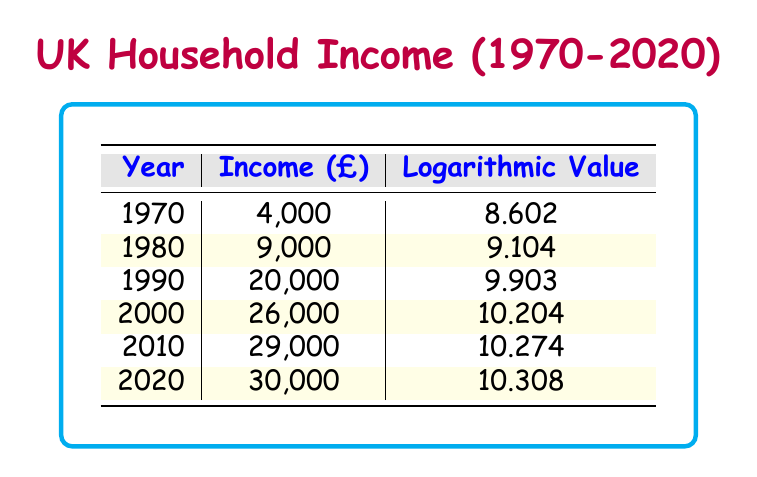What was the average annual household income in 1990? The table directly shows that the income for the year 1990 is listed as 20,000.
Answer: 20,000 What is the logarithmic value for the year 2000? Referring to the table, the logarithmic value corresponding to the year 2000 is 10.204.
Answer: 10.204 Was the average annual household income higher in 2010 than in 2020? By comparing the incomes for both years, 2010 has an income of 29,000 while 2020 has an income of 30,000. Since 30,000 is greater than 29,000, the statement is false.
Answer: No What was the difference in average household income from 1970 to 2020? The income in 1970 was 4,000, and in 2020 it was 30,000. To find the difference, we subtract 4,000 from 30,000, which gives us 26,000.
Answer: 26,000 What is the average annual household income from 1980 to 2020? The incomes from 1980 (9,000), 1990 (20,000), 2000 (26,000), 2010 (29,000), and 2020 (30,000) total to 114,000. Dividing by the 5 years gives an average of 22,800.
Answer: 22,800 Is the logarithmic value consistently increasing over the years in the table? By examining the logarithmic values: 8.602, 9.104, 9.903, 10.204, 10.274, 10.308, we can see that each successive value is greater than the last. Thus, yes, the values are consistently increasing.
Answer: Yes What percentage increase in income occurred from 1990 to 2000? The income in 1990 was 20,000 and in 2000 was 26,000. To find the increase, we subtract 20,000 from 26,000 to get 6,000. Then, we divide this by 20,000 and multiply by 100 to get the percentage: (6,000 / 20,000) * 100 = 30%.
Answer: 30% How much did the average annual household income increase from 1980 to 1990? The income in 1980 was 9,000 and in 1990 it was 20,000. To find the increase, we subtract 9,000 from 20,000, which gives us 11,000.
Answer: 11,000 